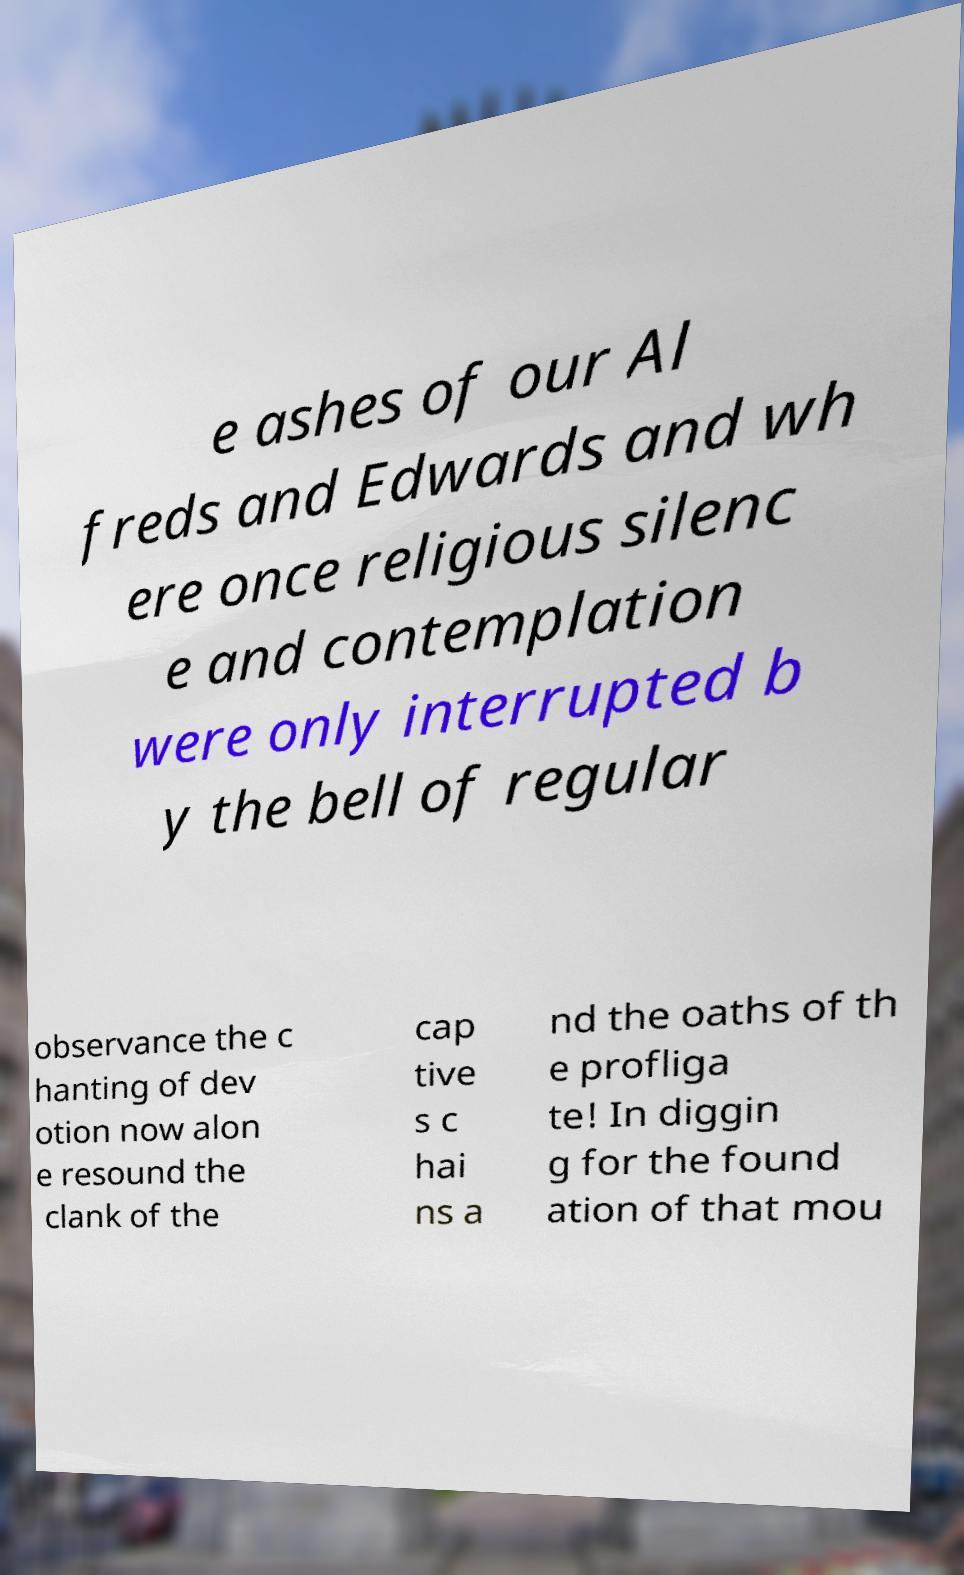I need the written content from this picture converted into text. Can you do that? e ashes of our Al freds and Edwards and wh ere once religious silenc e and contemplation were only interrupted b y the bell of regular observance the c hanting of dev otion now alon e resound the clank of the cap tive s c hai ns a nd the oaths of th e profliga te! In diggin g for the found ation of that mou 